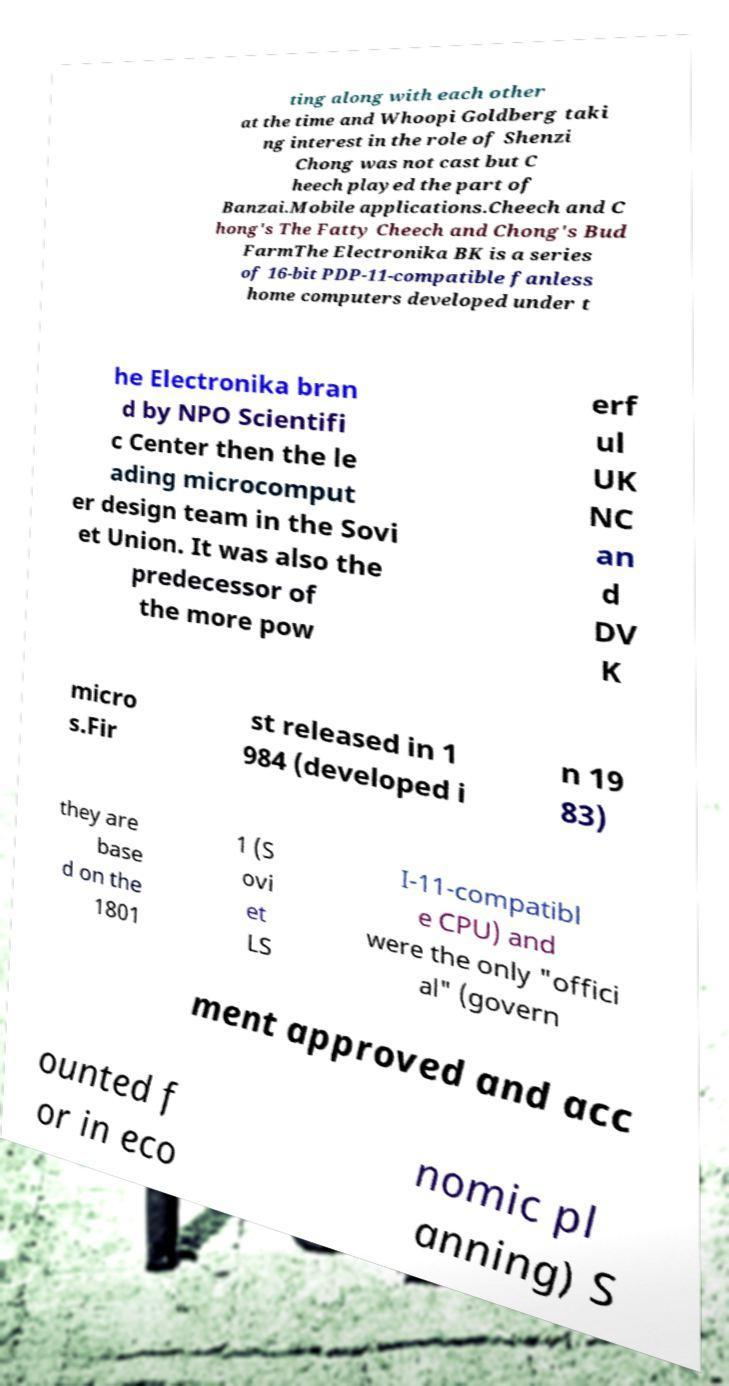What messages or text are displayed in this image? I need them in a readable, typed format. ting along with each other at the time and Whoopi Goldberg taki ng interest in the role of Shenzi Chong was not cast but C heech played the part of Banzai.Mobile applications.Cheech and C hong's The Fatty Cheech and Chong's Bud FarmThe Electronika BK is a series of 16-bit PDP-11-compatible fanless home computers developed under t he Electronika bran d by NPO Scientifi c Center then the le ading microcomput er design team in the Sovi et Union. It was also the predecessor of the more pow erf ul UK NC an d DV K micro s.Fir st released in 1 984 (developed i n 19 83) they are base d on the 1801 1 (S ovi et LS I-11-compatibl e CPU) and were the only "offici al" (govern ment approved and acc ounted f or in eco nomic pl anning) S 